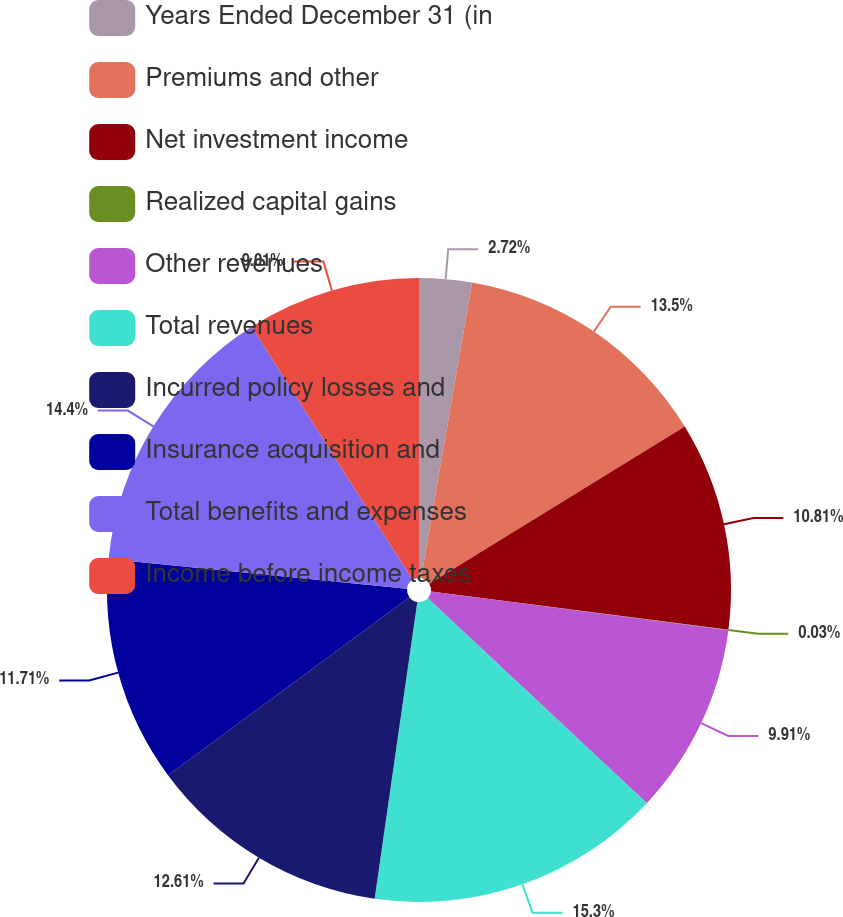Convert chart to OTSL. <chart><loc_0><loc_0><loc_500><loc_500><pie_chart><fcel>Years Ended December 31 (in<fcel>Premiums and other<fcel>Net investment income<fcel>Realized capital gains<fcel>Other revenues<fcel>Total revenues<fcel>Incurred policy losses and<fcel>Insurance acquisition and<fcel>Total benefits and expenses<fcel>Income before income taxes<nl><fcel>2.72%<fcel>13.5%<fcel>10.81%<fcel>0.03%<fcel>9.91%<fcel>15.3%<fcel>12.61%<fcel>11.71%<fcel>14.4%<fcel>9.01%<nl></chart> 